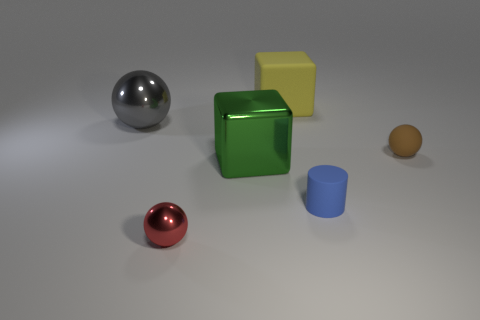Add 1 yellow objects. How many objects exist? 7 Subtract all cylinders. How many objects are left? 5 Subtract all cyan shiny balls. Subtract all small metal things. How many objects are left? 5 Add 4 small brown spheres. How many small brown spheres are left? 5 Add 4 spheres. How many spheres exist? 7 Subtract 0 gray cylinders. How many objects are left? 6 